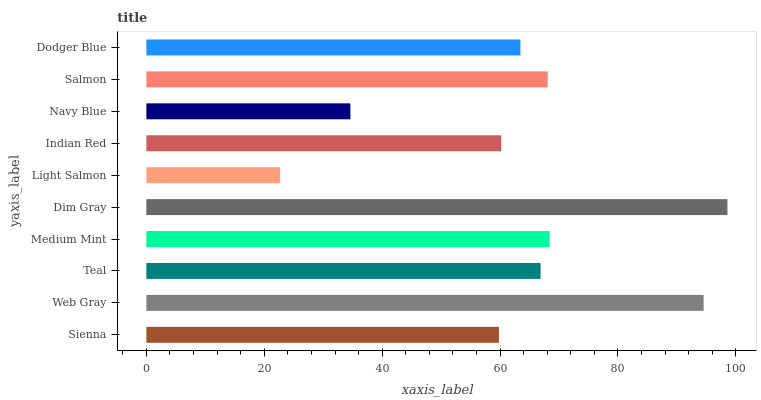Is Light Salmon the minimum?
Answer yes or no. Yes. Is Dim Gray the maximum?
Answer yes or no. Yes. Is Web Gray the minimum?
Answer yes or no. No. Is Web Gray the maximum?
Answer yes or no. No. Is Web Gray greater than Sienna?
Answer yes or no. Yes. Is Sienna less than Web Gray?
Answer yes or no. Yes. Is Sienna greater than Web Gray?
Answer yes or no. No. Is Web Gray less than Sienna?
Answer yes or no. No. Is Teal the high median?
Answer yes or no. Yes. Is Dodger Blue the low median?
Answer yes or no. Yes. Is Light Salmon the high median?
Answer yes or no. No. Is Light Salmon the low median?
Answer yes or no. No. 